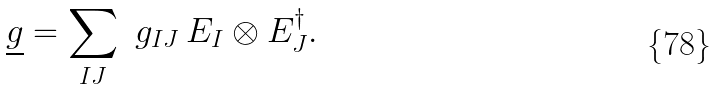<formula> <loc_0><loc_0><loc_500><loc_500>\underline { g } = \sum _ { I J } \ g _ { I J } \, E _ { I } \otimes E _ { J } ^ { \dagger } .</formula> 